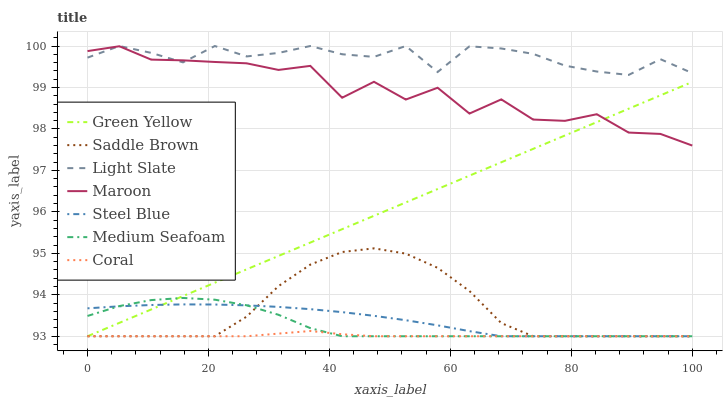Does Coral have the minimum area under the curve?
Answer yes or no. Yes. Does Light Slate have the maximum area under the curve?
Answer yes or no. Yes. Does Steel Blue have the minimum area under the curve?
Answer yes or no. No. Does Steel Blue have the maximum area under the curve?
Answer yes or no. No. Is Green Yellow the smoothest?
Answer yes or no. Yes. Is Maroon the roughest?
Answer yes or no. Yes. Is Coral the smoothest?
Answer yes or no. No. Is Coral the roughest?
Answer yes or no. No. Does Coral have the lowest value?
Answer yes or no. Yes. Does Maroon have the lowest value?
Answer yes or no. No. Does Light Slate have the highest value?
Answer yes or no. Yes. Does Steel Blue have the highest value?
Answer yes or no. No. Is Saddle Brown less than Light Slate?
Answer yes or no. Yes. Is Maroon greater than Coral?
Answer yes or no. Yes. Does Saddle Brown intersect Coral?
Answer yes or no. Yes. Is Saddle Brown less than Coral?
Answer yes or no. No. Is Saddle Brown greater than Coral?
Answer yes or no. No. Does Saddle Brown intersect Light Slate?
Answer yes or no. No. 